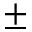<formula> <loc_0><loc_0><loc_500><loc_500>\pm</formula> 